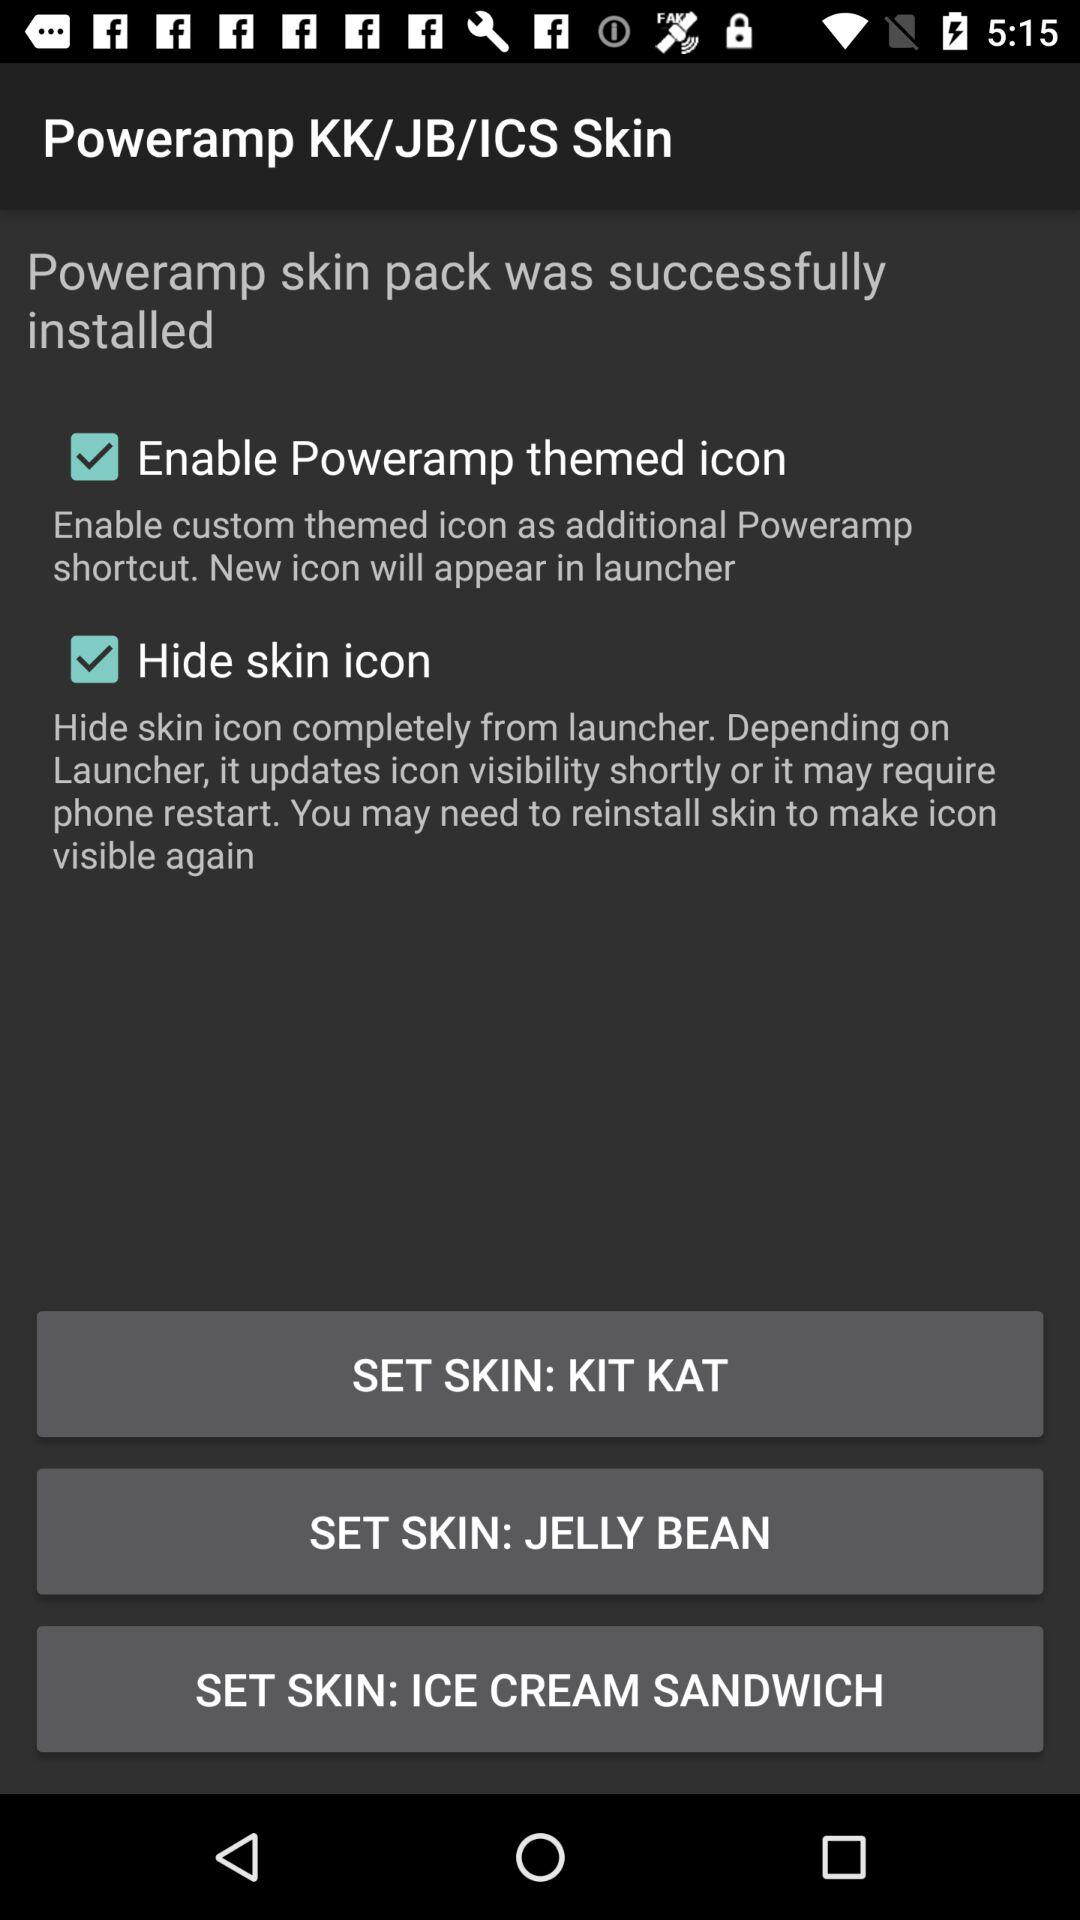What is the username?
When the provided information is insufficient, respond with <no answer>. <no answer> 